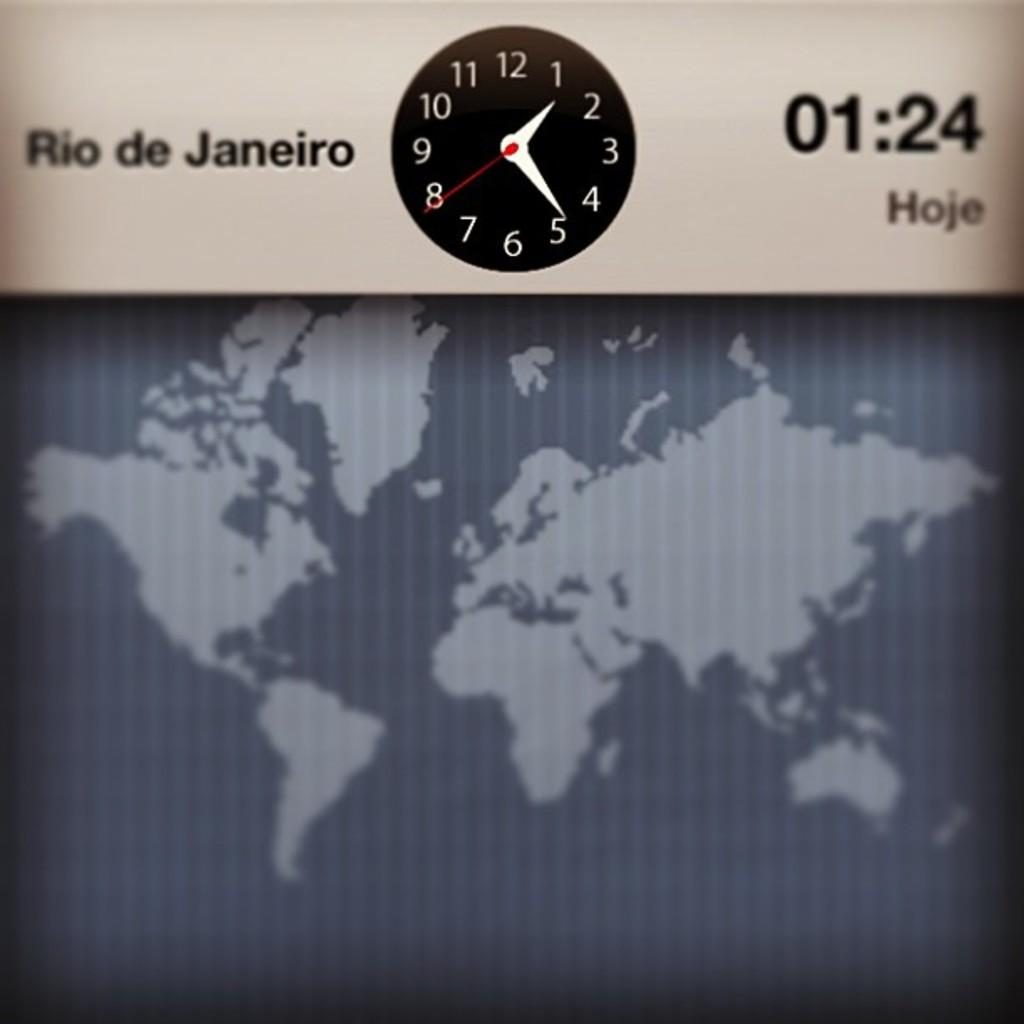<image>
Give a short and clear explanation of the subsequent image. the time is 01:24 on the map that has a clock near 